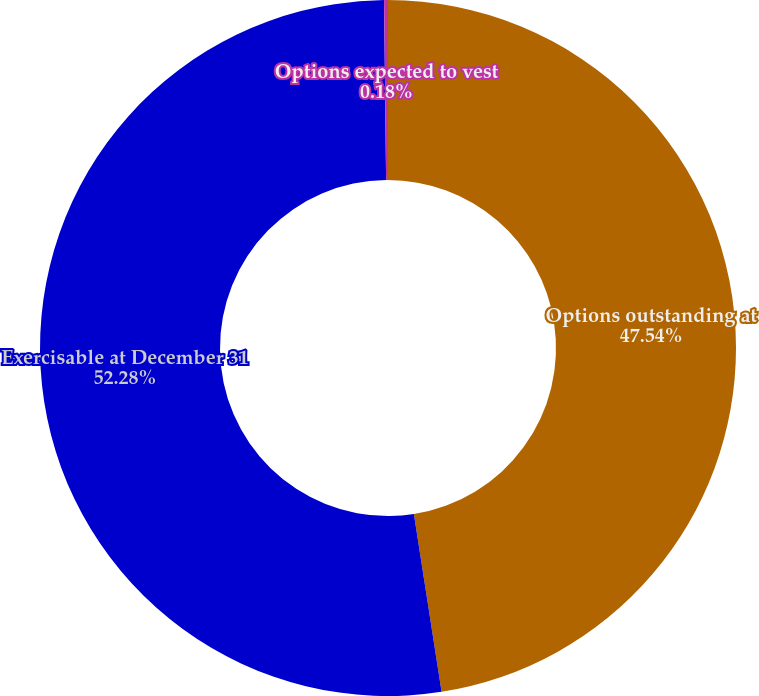Convert chart to OTSL. <chart><loc_0><loc_0><loc_500><loc_500><pie_chart><fcel>Options outstanding at<fcel>Exercisable at December 31<fcel>Options expected to vest<nl><fcel>47.54%<fcel>52.28%<fcel>0.18%<nl></chart> 